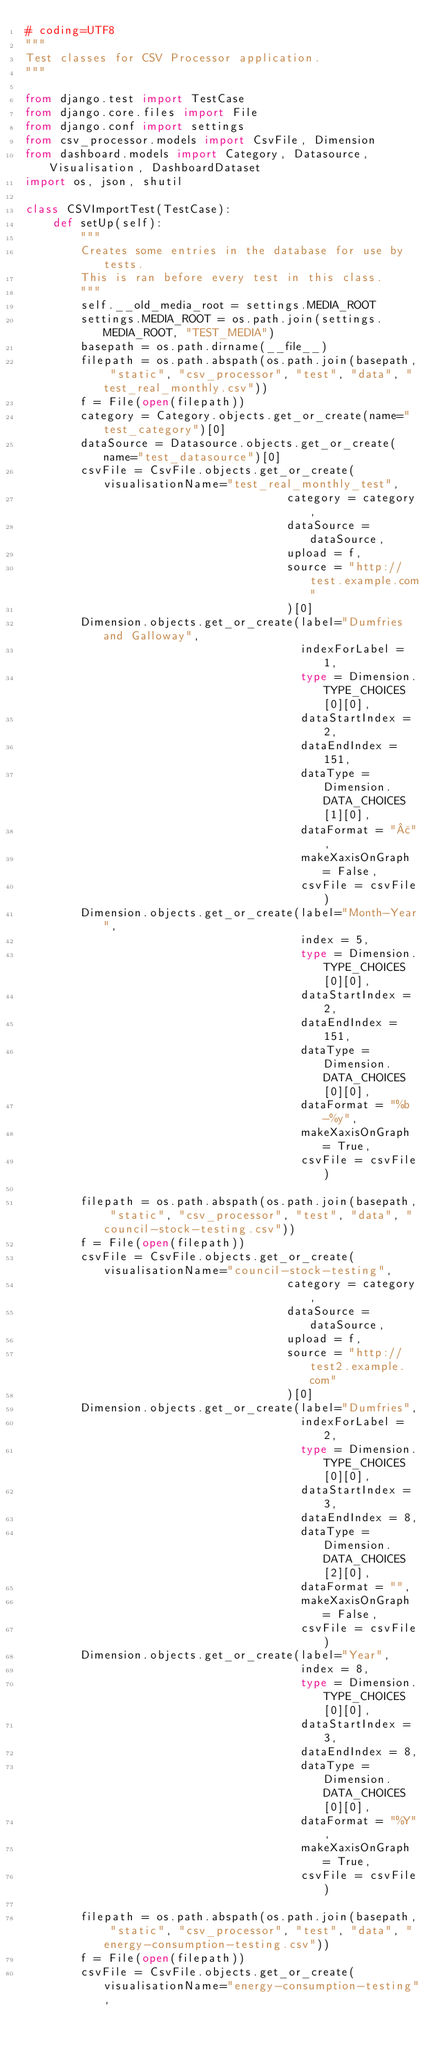Convert code to text. <code><loc_0><loc_0><loc_500><loc_500><_Python_># coding=UTF8
"""
Test classes for CSV Processor application.
"""

from django.test import TestCase
from django.core.files import File
from django.conf import settings
from csv_processor.models import CsvFile, Dimension
from dashboard.models import Category, Datasource, Visualisation, DashboardDataset
import os, json, shutil

class CSVImportTest(TestCase):
    def setUp(self):
        """
        Creates some entries in the database for use by tests.
        This is ran before every test in this class.
        """
        self.__old_media_root = settings.MEDIA_ROOT
        settings.MEDIA_ROOT = os.path.join(settings.MEDIA_ROOT, "TEST_MEDIA")
        basepath = os.path.dirname(__file__)
        filepath = os.path.abspath(os.path.join(basepath, "static", "csv_processor", "test", "data", "test_real_monthly.csv"))
        f = File(open(filepath))
        category = Category.objects.get_or_create(name="test_category")[0]
        dataSource = Datasource.objects.get_or_create(name="test_datasource")[0]
        csvFile = CsvFile.objects.get_or_create(visualisationName="test_real_monthly_test",
                                      category = category,
                                      dataSource = dataSource,
                                      upload = f,
                                      source = "http://test.example.com"
                                      )[0]
        Dimension.objects.get_or_create(label="Dumfries and Galloway",
                                        indexForLabel = 1,
                                        type = Dimension.TYPE_CHOICES[0][0],
                                        dataStartIndex = 2,
                                        dataEndIndex = 151,
                                        dataType = Dimension.DATA_CHOICES[1][0],
                                        dataFormat = "£",
                                        makeXaxisOnGraph = False,
                                        csvFile = csvFile)
        Dimension.objects.get_or_create(label="Month-Year",
                                        index = 5,
                                        type = Dimension.TYPE_CHOICES[0][0],
                                        dataStartIndex = 2,
                                        dataEndIndex = 151,
                                        dataType = Dimension.DATA_CHOICES[0][0],
                                        dataFormat = "%b-%y",
                                        makeXaxisOnGraph = True,
                                        csvFile = csvFile)
        
        filepath = os.path.abspath(os.path.join(basepath, "static", "csv_processor", "test", "data", "council-stock-testing.csv"))
        f = File(open(filepath))
        csvFile = CsvFile.objects.get_or_create(visualisationName="council-stock-testing",
                                      category = category,
                                      dataSource = dataSource,
                                      upload = f,
                                      source = "http://test2.example.com"
                                      )[0]
        Dimension.objects.get_or_create(label="Dumfries",
                                        indexForLabel = 2,
                                        type = Dimension.TYPE_CHOICES[0][0],
                                        dataStartIndex = 3,
                                        dataEndIndex = 8,
                                        dataType = Dimension.DATA_CHOICES[2][0],
                                        dataFormat = "",
                                        makeXaxisOnGraph = False,
                                        csvFile = csvFile)
        Dimension.objects.get_or_create(label="Year",
                                        index = 8,
                                        type = Dimension.TYPE_CHOICES[0][0],
                                        dataStartIndex = 3,
                                        dataEndIndex = 8,
                                        dataType = Dimension.DATA_CHOICES[0][0],
                                        dataFormat = "%Y",
                                        makeXaxisOnGraph = True,
                                        csvFile = csvFile)
        
        filepath = os.path.abspath(os.path.join(basepath, "static", "csv_processor", "test", "data", "energy-consumption-testing.csv"))
        f = File(open(filepath))
        csvFile = CsvFile.objects.get_or_create(visualisationName="energy-consumption-testing",</code> 